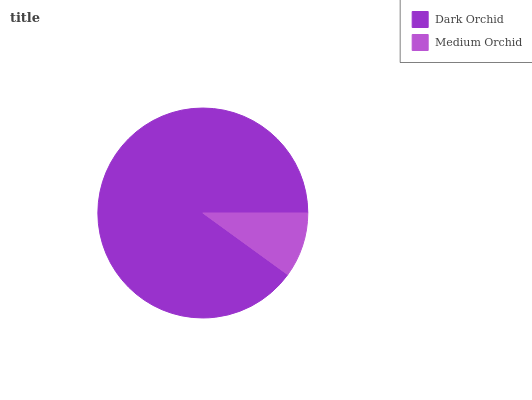Is Medium Orchid the minimum?
Answer yes or no. Yes. Is Dark Orchid the maximum?
Answer yes or no. Yes. Is Medium Orchid the maximum?
Answer yes or no. No. Is Dark Orchid greater than Medium Orchid?
Answer yes or no. Yes. Is Medium Orchid less than Dark Orchid?
Answer yes or no. Yes. Is Medium Orchid greater than Dark Orchid?
Answer yes or no. No. Is Dark Orchid less than Medium Orchid?
Answer yes or no. No. Is Dark Orchid the high median?
Answer yes or no. Yes. Is Medium Orchid the low median?
Answer yes or no. Yes. Is Medium Orchid the high median?
Answer yes or no. No. Is Dark Orchid the low median?
Answer yes or no. No. 